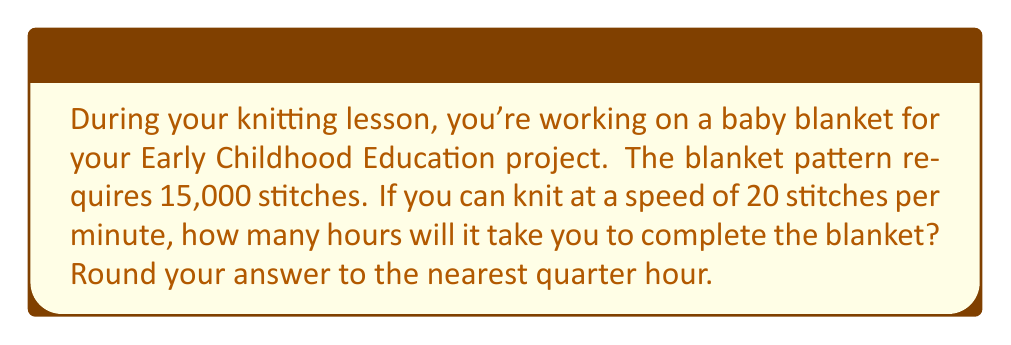Could you help me with this problem? To solve this problem, we need to follow these steps:

1. Calculate the total number of minutes required:
   Let $x$ be the number of minutes needed.
   $$x = \frac{\text{Total stitches}}{\text{Stitches per minute}}$$
   $$x = \frac{15,000}{20} = 750 \text{ minutes}$$

2. Convert minutes to hours:
   $$\text{Hours} = \frac{\text{Minutes}}{60}$$
   $$\text{Hours} = \frac{750}{60} = 12.5 \text{ hours}$$

3. Round to the nearest quarter hour:
   12.5 hours is exactly halfway between 12.25 and 12.75 hours.
   In this case, we round up to 12.75 hours.

Therefore, it will take 12.75 hours (or 12 hours and 45 minutes) to complete the blanket.
Answer: 12.75 hours 